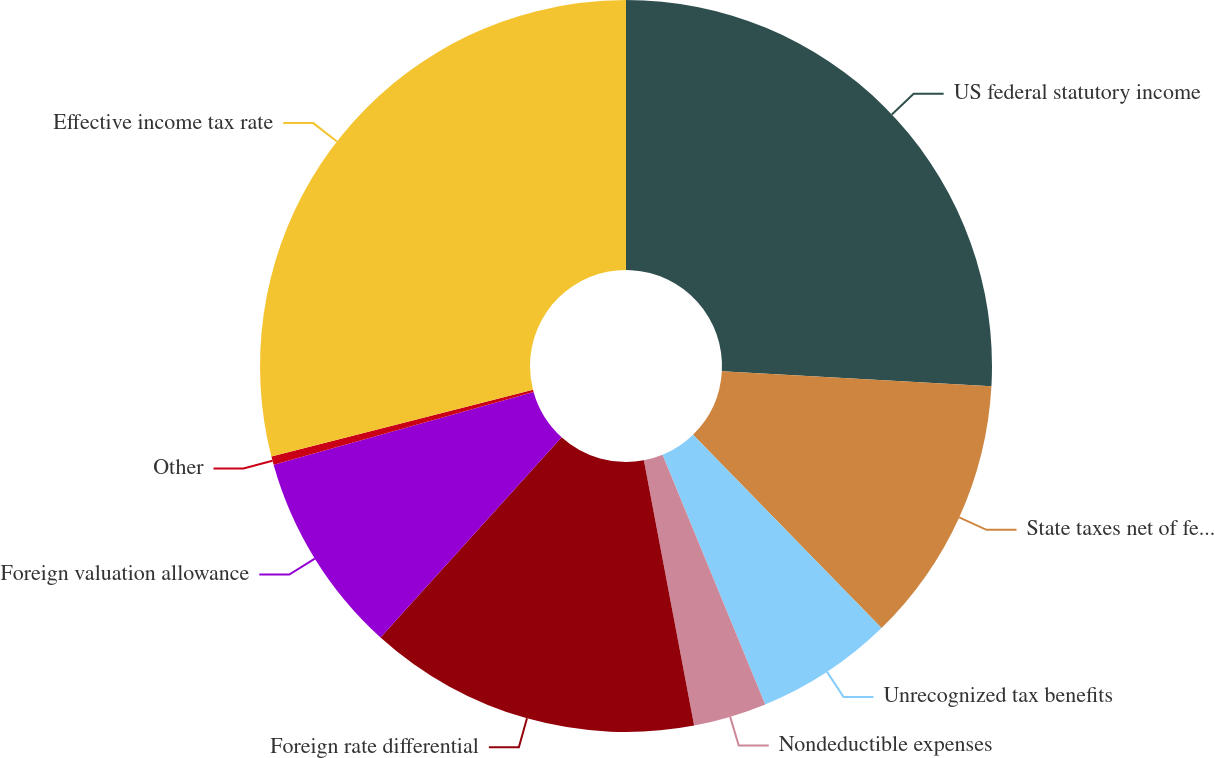Convert chart. <chart><loc_0><loc_0><loc_500><loc_500><pie_chart><fcel>US federal statutory income<fcel>State taxes net of federal tax<fcel>Unrecognized tax benefits<fcel>Nondeductible expenses<fcel>Foreign rate differential<fcel>Foreign valuation allowance<fcel>Other<fcel>Effective income tax rate<nl><fcel>25.88%<fcel>11.82%<fcel>6.09%<fcel>3.23%<fcel>14.68%<fcel>8.95%<fcel>0.37%<fcel>28.98%<nl></chart> 